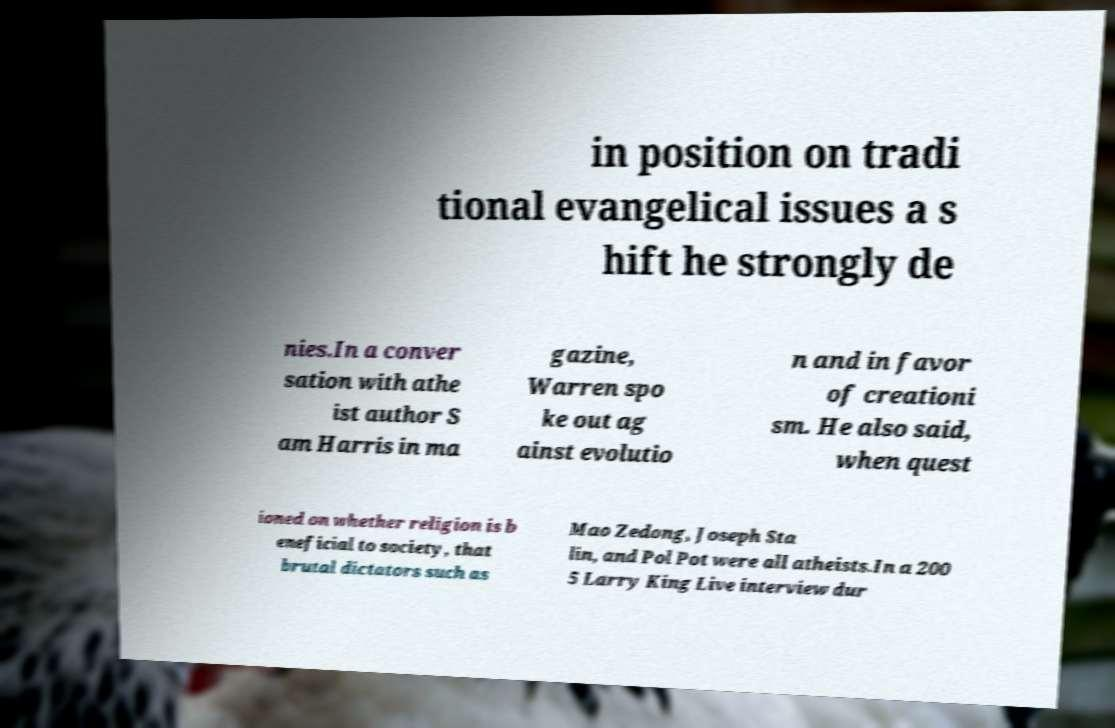Can you accurately transcribe the text from the provided image for me? in position on tradi tional evangelical issues a s hift he strongly de nies.In a conver sation with athe ist author S am Harris in ma gazine, Warren spo ke out ag ainst evolutio n and in favor of creationi sm. He also said, when quest ioned on whether religion is b eneficial to society, that brutal dictators such as Mao Zedong, Joseph Sta lin, and Pol Pot were all atheists.In a 200 5 Larry King Live interview dur 